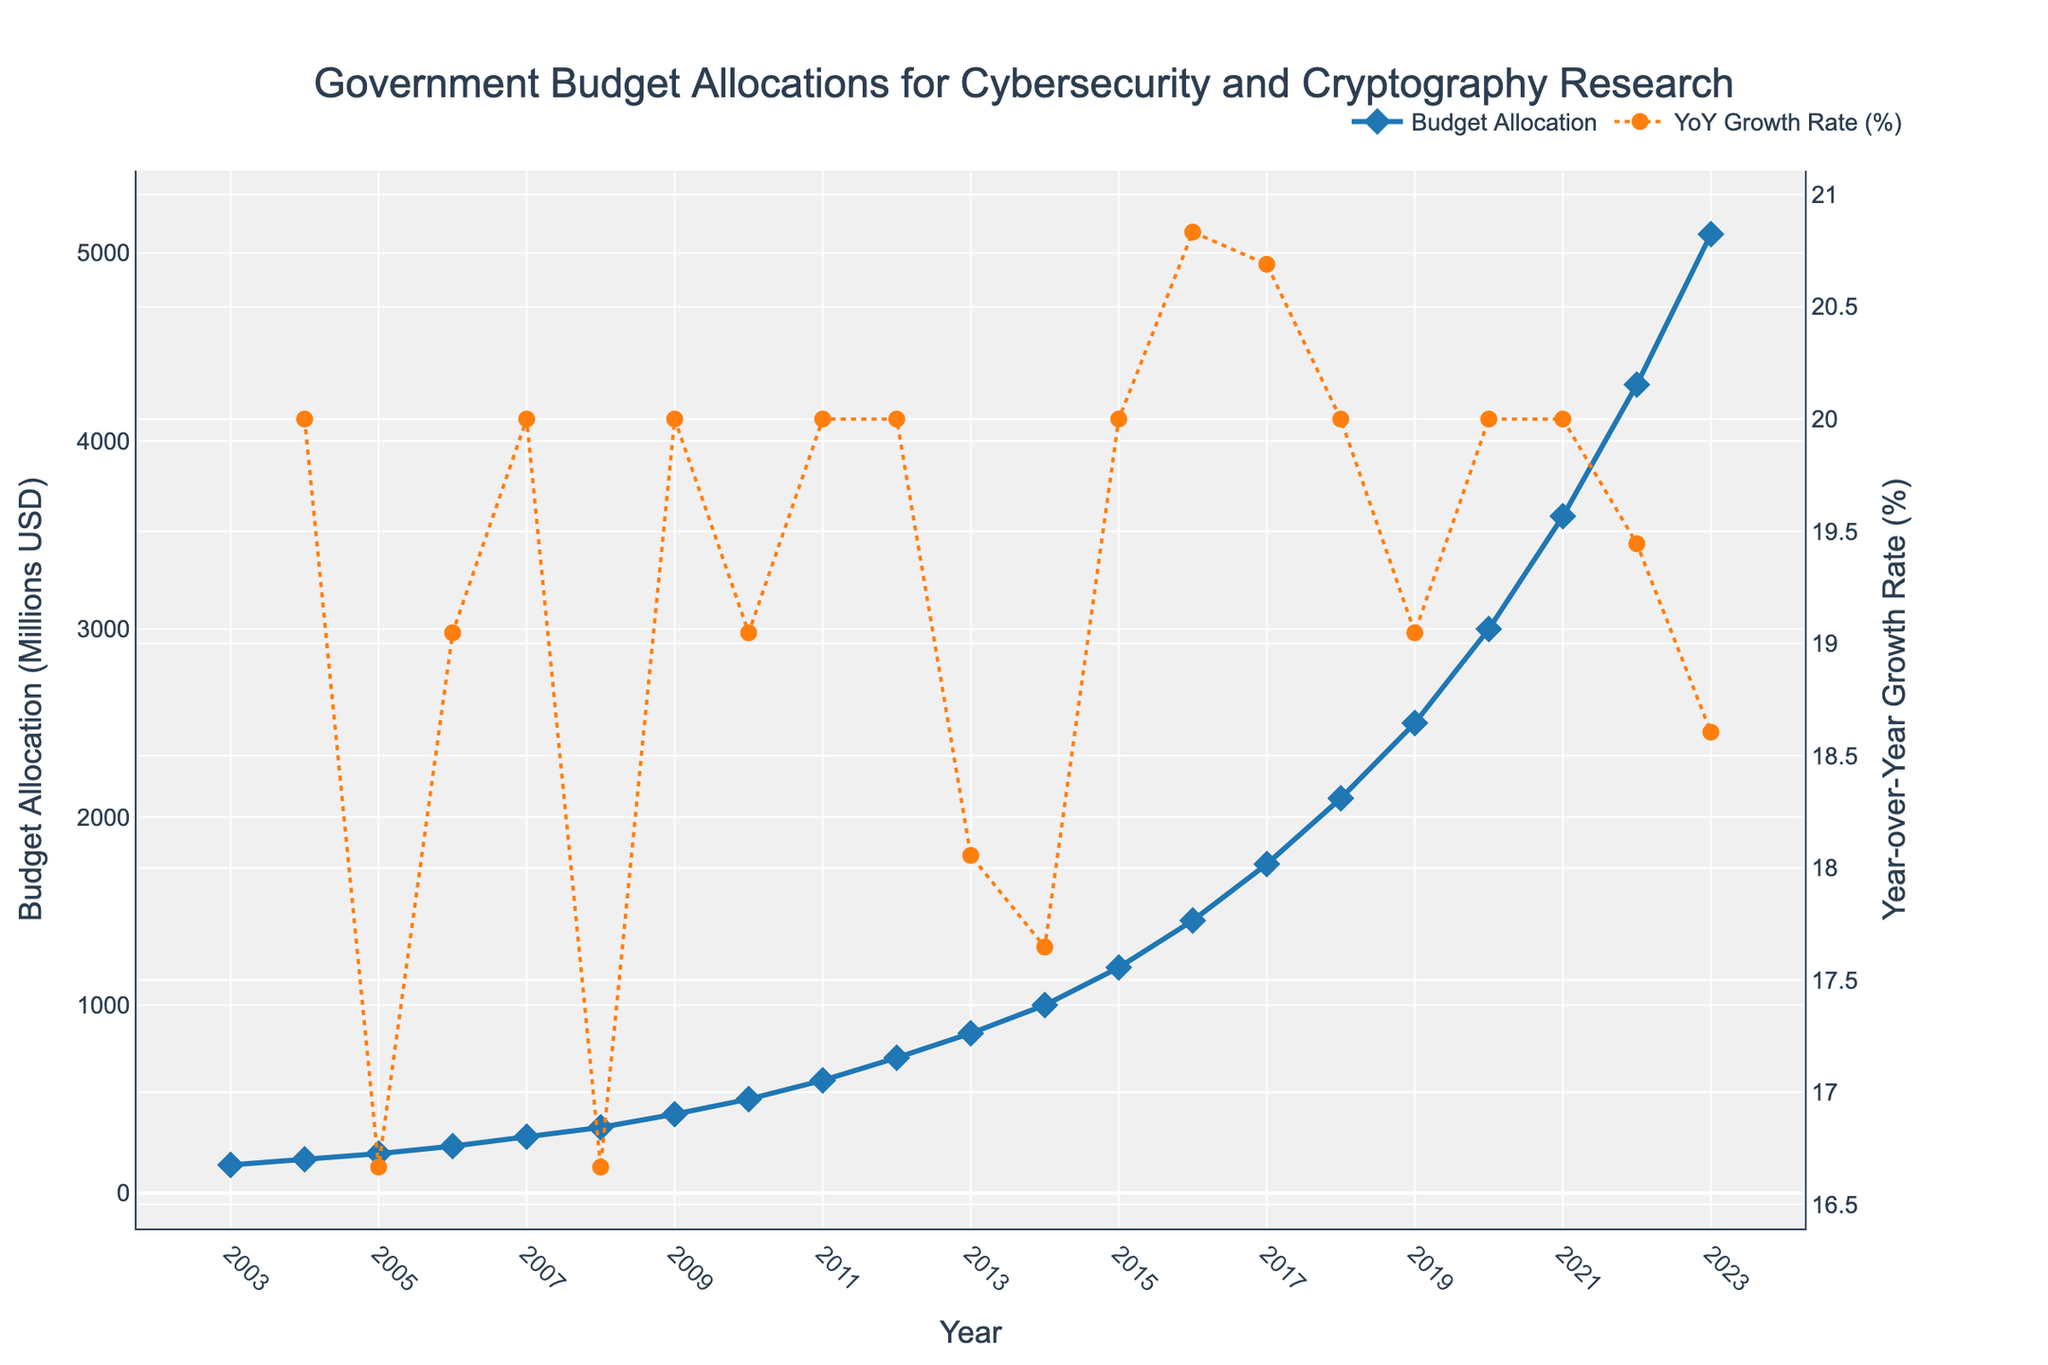What is the budget allocation for cybersecurity and cryptography research in 2015? To find the budget allocation for 2015, locate the year 2015 on the x-axis and find the corresponding point on the y-axis.
Answer: 1200 million USD How much did the budget allocation increase from 2010 to 2015? To determine the increase, subtract the budget in 2010 from the budget in 2015: 1200 million USD (2015) - 500 million USD (2010).
Answer: 700 million USD In which year did the budget allocation first exceed 1000 million USD? To find the first year the allocation exceeded 1000 million USD, look at the y-axis and track along the x-axis to find the corresponding year.
Answer: 2014 What is the highest year-over-year growth rate percentage observed in the figure? To determine the highest growth rate, look for the peak value in the secondary y-axis representing the YoY Growth Rate (%). Find the corresponding percentage value.
Answer: 2021 How many years did it take for the budget allocation to grow from 150 million to 1000 million USD? To find the duration, identify the years when the budget was 150 million USD (2003) and when it reached 1000 million USD (2014). Subtract 2003 from 2014: 2014 - 2003.
Answer: 11 years Which year had the smallest increase in budget allocation compared to the previous year? Examine the YoY Growth Rate (%) on the secondary y-axis to find the lowest positive value. Compare the corresponding years to identify the smallest increase.
Answer: 2004 How does the growth rate in 2023 compare to the growth rate in 2018? Locate the growth rates for both years on the secondary y-axis. Compare the two values to determine which is higher or if they are equal.
Answer: Higher in 2023 What is the average annual budget allocation from 2010 to 2020? Sum the budget allocations from 2010 to 2020 and divide by the number of years (11). (500 + 600 + 720 + 850 + 1000 + 1200 + 1450 + 1750 + 2100 + 2500 + 3000) / 11 = 1610.91 million USD
Answer: 1610.91 million USD Between 2017 and 2022, which year experienced the largest budget allocation increase? Identify the allocation values for each year between 2017 and 2022, then calculate the yearly increases and find the maximum. 2022: 700 million USD increase.
Answer: 2022 What is the overall trend of the budget allocation for cybersecurity and cryptography research from 2003 to 2023? Observe the overall shape of the budget allocation line on the graph. Determine if the line's general direction is upwards, downwards, or stable.
Answer: Upwards 